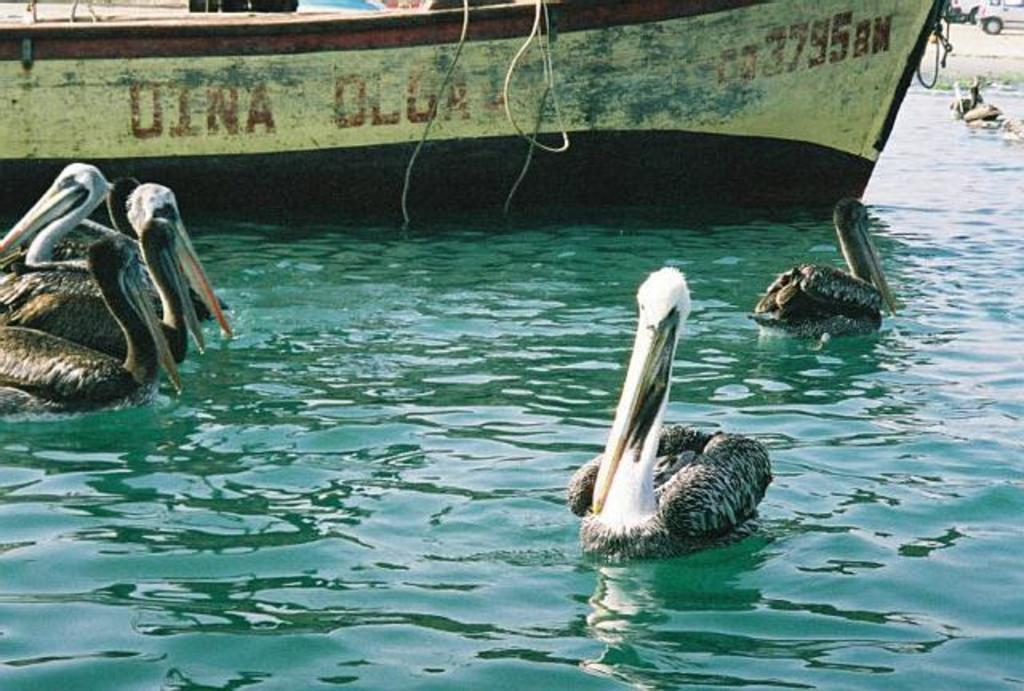What type of animals can be seen in the image? Birds can be seen in the image. What color are the birds in the image? The birds are in black and white color. What is the birds' location in the image? The birds are in the water. What else can be seen in the water besides the birds? There is a boat on the water. What can be seen in the background of the image? Vehicles are visible in the background. What attempt did the birds make to achieve a higher level of self-awareness in the image? There is no indication in the image that the birds are attempting to achieve a higher level of self-awareness or that they are even aware of their own existence. 